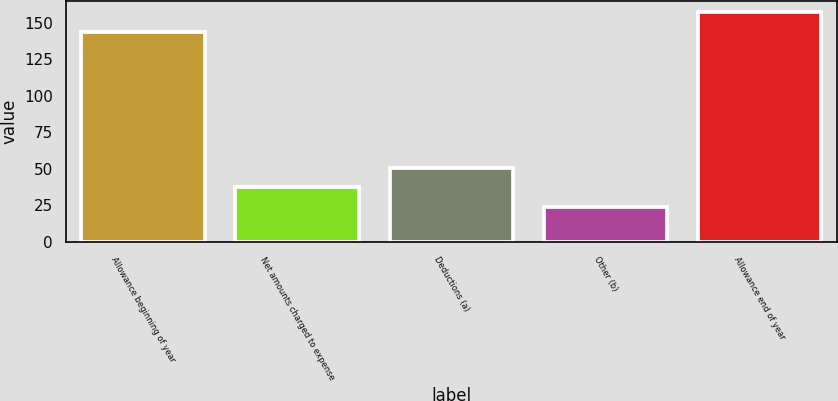<chart> <loc_0><loc_0><loc_500><loc_500><bar_chart><fcel>Allowance beginning of year<fcel>Net amounts charged to expense<fcel>Deductions (a)<fcel>Other (b)<fcel>Allowance end of year<nl><fcel>144<fcel>37.3<fcel>50.6<fcel>24<fcel>157.3<nl></chart> 